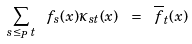Convert formula to latex. <formula><loc_0><loc_0><loc_500><loc_500>\sum _ { s \leq _ { P } \, t } \ f _ { s } ( x ) \kappa _ { s t } ( x ) \ = \ \overline { f } _ { t } ( x )</formula> 